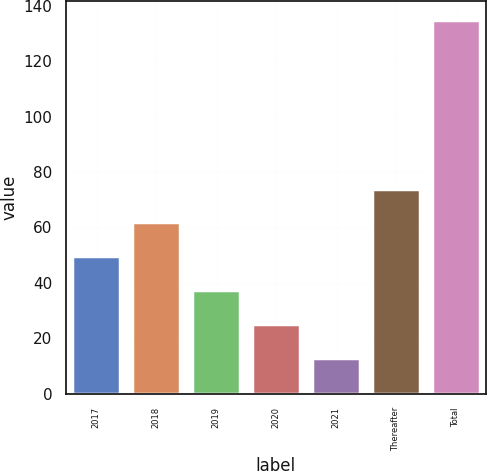Convert chart. <chart><loc_0><loc_0><loc_500><loc_500><bar_chart><fcel>2017<fcel>2018<fcel>2019<fcel>2020<fcel>2021<fcel>Thereafter<fcel>Total<nl><fcel>49.64<fcel>61.82<fcel>37.46<fcel>25.28<fcel>13.1<fcel>74<fcel>134.9<nl></chart> 